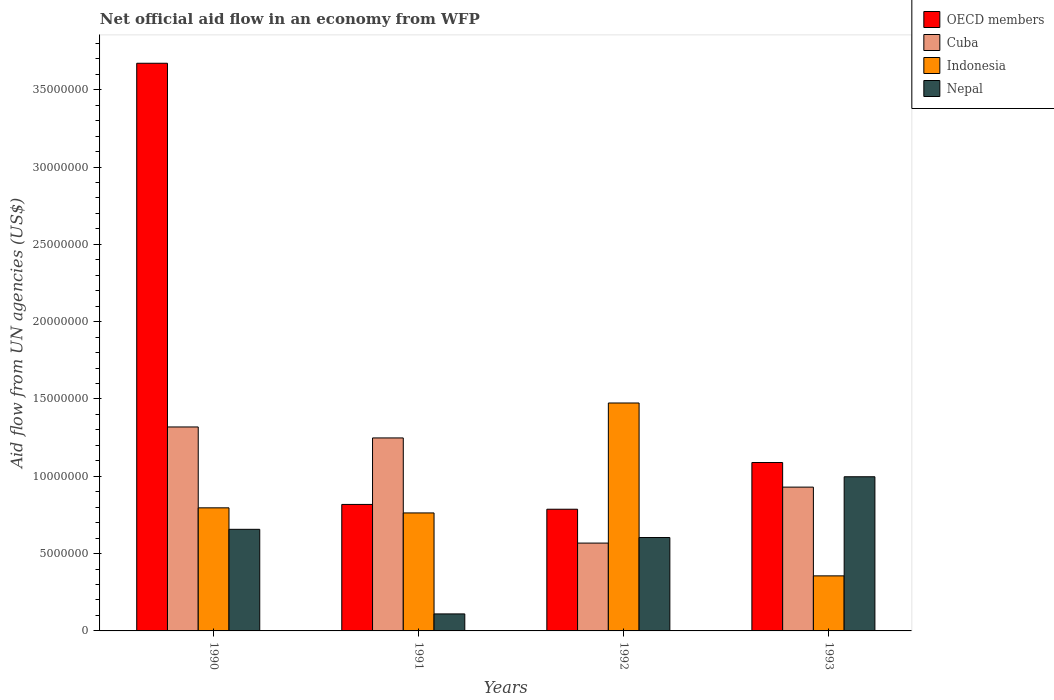How many bars are there on the 1st tick from the left?
Make the answer very short. 4. In how many cases, is the number of bars for a given year not equal to the number of legend labels?
Provide a short and direct response. 0. What is the net official aid flow in Nepal in 1993?
Offer a very short reply. 9.97e+06. Across all years, what is the maximum net official aid flow in Nepal?
Keep it short and to the point. 9.97e+06. Across all years, what is the minimum net official aid flow in Cuba?
Make the answer very short. 5.68e+06. In which year was the net official aid flow in Cuba minimum?
Make the answer very short. 1992. What is the total net official aid flow in Cuba in the graph?
Make the answer very short. 4.06e+07. What is the difference between the net official aid flow in Nepal in 1991 and the net official aid flow in Indonesia in 1990?
Your response must be concise. -6.86e+06. What is the average net official aid flow in OECD members per year?
Ensure brevity in your answer.  1.59e+07. In the year 1990, what is the difference between the net official aid flow in Nepal and net official aid flow in Indonesia?
Your answer should be compact. -1.39e+06. In how many years, is the net official aid flow in Cuba greater than 33000000 US$?
Offer a very short reply. 0. What is the ratio of the net official aid flow in Indonesia in 1991 to that in 1992?
Your answer should be compact. 0.52. What is the difference between the highest and the second highest net official aid flow in Cuba?
Your answer should be very brief. 7.10e+05. What is the difference between the highest and the lowest net official aid flow in Indonesia?
Offer a terse response. 1.12e+07. In how many years, is the net official aid flow in Nepal greater than the average net official aid flow in Nepal taken over all years?
Provide a short and direct response. 3. Is it the case that in every year, the sum of the net official aid flow in Cuba and net official aid flow in Indonesia is greater than the sum of net official aid flow in Nepal and net official aid flow in OECD members?
Offer a terse response. Yes. What does the 4th bar from the left in 1993 represents?
Make the answer very short. Nepal. What does the 4th bar from the right in 1993 represents?
Make the answer very short. OECD members. Are all the bars in the graph horizontal?
Keep it short and to the point. No. What is the difference between two consecutive major ticks on the Y-axis?
Your answer should be compact. 5.00e+06. Are the values on the major ticks of Y-axis written in scientific E-notation?
Offer a very short reply. No. Does the graph contain any zero values?
Provide a succinct answer. No. Where does the legend appear in the graph?
Your response must be concise. Top right. How many legend labels are there?
Keep it short and to the point. 4. How are the legend labels stacked?
Give a very brief answer. Vertical. What is the title of the graph?
Offer a terse response. Net official aid flow in an economy from WFP. Does "Turkey" appear as one of the legend labels in the graph?
Give a very brief answer. No. What is the label or title of the Y-axis?
Give a very brief answer. Aid flow from UN agencies (US$). What is the Aid flow from UN agencies (US$) of OECD members in 1990?
Make the answer very short. 3.67e+07. What is the Aid flow from UN agencies (US$) of Cuba in 1990?
Your answer should be very brief. 1.32e+07. What is the Aid flow from UN agencies (US$) of Indonesia in 1990?
Your response must be concise. 7.96e+06. What is the Aid flow from UN agencies (US$) of Nepal in 1990?
Give a very brief answer. 6.57e+06. What is the Aid flow from UN agencies (US$) of OECD members in 1991?
Make the answer very short. 8.18e+06. What is the Aid flow from UN agencies (US$) of Cuba in 1991?
Provide a short and direct response. 1.25e+07. What is the Aid flow from UN agencies (US$) of Indonesia in 1991?
Provide a succinct answer. 7.63e+06. What is the Aid flow from UN agencies (US$) in Nepal in 1991?
Provide a short and direct response. 1.10e+06. What is the Aid flow from UN agencies (US$) of OECD members in 1992?
Keep it short and to the point. 7.87e+06. What is the Aid flow from UN agencies (US$) in Cuba in 1992?
Provide a short and direct response. 5.68e+06. What is the Aid flow from UN agencies (US$) in Indonesia in 1992?
Your answer should be very brief. 1.47e+07. What is the Aid flow from UN agencies (US$) of Nepal in 1992?
Offer a terse response. 6.04e+06. What is the Aid flow from UN agencies (US$) in OECD members in 1993?
Give a very brief answer. 1.09e+07. What is the Aid flow from UN agencies (US$) in Cuba in 1993?
Offer a very short reply. 9.30e+06. What is the Aid flow from UN agencies (US$) of Indonesia in 1993?
Ensure brevity in your answer.  3.56e+06. What is the Aid flow from UN agencies (US$) in Nepal in 1993?
Give a very brief answer. 9.97e+06. Across all years, what is the maximum Aid flow from UN agencies (US$) in OECD members?
Offer a terse response. 3.67e+07. Across all years, what is the maximum Aid flow from UN agencies (US$) of Cuba?
Keep it short and to the point. 1.32e+07. Across all years, what is the maximum Aid flow from UN agencies (US$) of Indonesia?
Provide a short and direct response. 1.47e+07. Across all years, what is the maximum Aid flow from UN agencies (US$) of Nepal?
Provide a short and direct response. 9.97e+06. Across all years, what is the minimum Aid flow from UN agencies (US$) in OECD members?
Your response must be concise. 7.87e+06. Across all years, what is the minimum Aid flow from UN agencies (US$) of Cuba?
Offer a terse response. 5.68e+06. Across all years, what is the minimum Aid flow from UN agencies (US$) in Indonesia?
Ensure brevity in your answer.  3.56e+06. Across all years, what is the minimum Aid flow from UN agencies (US$) in Nepal?
Make the answer very short. 1.10e+06. What is the total Aid flow from UN agencies (US$) in OECD members in the graph?
Keep it short and to the point. 6.36e+07. What is the total Aid flow from UN agencies (US$) in Cuba in the graph?
Provide a short and direct response. 4.06e+07. What is the total Aid flow from UN agencies (US$) of Indonesia in the graph?
Make the answer very short. 3.39e+07. What is the total Aid flow from UN agencies (US$) in Nepal in the graph?
Offer a very short reply. 2.37e+07. What is the difference between the Aid flow from UN agencies (US$) in OECD members in 1990 and that in 1991?
Provide a short and direct response. 2.85e+07. What is the difference between the Aid flow from UN agencies (US$) of Cuba in 1990 and that in 1991?
Offer a terse response. 7.10e+05. What is the difference between the Aid flow from UN agencies (US$) in Nepal in 1990 and that in 1991?
Offer a terse response. 5.47e+06. What is the difference between the Aid flow from UN agencies (US$) of OECD members in 1990 and that in 1992?
Make the answer very short. 2.88e+07. What is the difference between the Aid flow from UN agencies (US$) in Cuba in 1990 and that in 1992?
Ensure brevity in your answer.  7.51e+06. What is the difference between the Aid flow from UN agencies (US$) in Indonesia in 1990 and that in 1992?
Give a very brief answer. -6.78e+06. What is the difference between the Aid flow from UN agencies (US$) of Nepal in 1990 and that in 1992?
Your response must be concise. 5.30e+05. What is the difference between the Aid flow from UN agencies (US$) of OECD members in 1990 and that in 1993?
Your answer should be very brief. 2.58e+07. What is the difference between the Aid flow from UN agencies (US$) of Cuba in 1990 and that in 1993?
Make the answer very short. 3.89e+06. What is the difference between the Aid flow from UN agencies (US$) in Indonesia in 1990 and that in 1993?
Offer a very short reply. 4.40e+06. What is the difference between the Aid flow from UN agencies (US$) in Nepal in 1990 and that in 1993?
Your answer should be very brief. -3.40e+06. What is the difference between the Aid flow from UN agencies (US$) of Cuba in 1991 and that in 1992?
Give a very brief answer. 6.80e+06. What is the difference between the Aid flow from UN agencies (US$) of Indonesia in 1991 and that in 1992?
Offer a very short reply. -7.11e+06. What is the difference between the Aid flow from UN agencies (US$) in Nepal in 1991 and that in 1992?
Make the answer very short. -4.94e+06. What is the difference between the Aid flow from UN agencies (US$) of OECD members in 1991 and that in 1993?
Ensure brevity in your answer.  -2.71e+06. What is the difference between the Aid flow from UN agencies (US$) in Cuba in 1991 and that in 1993?
Provide a succinct answer. 3.18e+06. What is the difference between the Aid flow from UN agencies (US$) in Indonesia in 1991 and that in 1993?
Offer a very short reply. 4.07e+06. What is the difference between the Aid flow from UN agencies (US$) in Nepal in 1991 and that in 1993?
Offer a very short reply. -8.87e+06. What is the difference between the Aid flow from UN agencies (US$) of OECD members in 1992 and that in 1993?
Your response must be concise. -3.02e+06. What is the difference between the Aid flow from UN agencies (US$) in Cuba in 1992 and that in 1993?
Your answer should be very brief. -3.62e+06. What is the difference between the Aid flow from UN agencies (US$) of Indonesia in 1992 and that in 1993?
Make the answer very short. 1.12e+07. What is the difference between the Aid flow from UN agencies (US$) in Nepal in 1992 and that in 1993?
Offer a terse response. -3.93e+06. What is the difference between the Aid flow from UN agencies (US$) of OECD members in 1990 and the Aid flow from UN agencies (US$) of Cuba in 1991?
Your answer should be compact. 2.42e+07. What is the difference between the Aid flow from UN agencies (US$) in OECD members in 1990 and the Aid flow from UN agencies (US$) in Indonesia in 1991?
Ensure brevity in your answer.  2.91e+07. What is the difference between the Aid flow from UN agencies (US$) in OECD members in 1990 and the Aid flow from UN agencies (US$) in Nepal in 1991?
Offer a very short reply. 3.56e+07. What is the difference between the Aid flow from UN agencies (US$) of Cuba in 1990 and the Aid flow from UN agencies (US$) of Indonesia in 1991?
Your response must be concise. 5.56e+06. What is the difference between the Aid flow from UN agencies (US$) in Cuba in 1990 and the Aid flow from UN agencies (US$) in Nepal in 1991?
Offer a terse response. 1.21e+07. What is the difference between the Aid flow from UN agencies (US$) of Indonesia in 1990 and the Aid flow from UN agencies (US$) of Nepal in 1991?
Your answer should be compact. 6.86e+06. What is the difference between the Aid flow from UN agencies (US$) of OECD members in 1990 and the Aid flow from UN agencies (US$) of Cuba in 1992?
Make the answer very short. 3.10e+07. What is the difference between the Aid flow from UN agencies (US$) in OECD members in 1990 and the Aid flow from UN agencies (US$) in Indonesia in 1992?
Give a very brief answer. 2.20e+07. What is the difference between the Aid flow from UN agencies (US$) in OECD members in 1990 and the Aid flow from UN agencies (US$) in Nepal in 1992?
Keep it short and to the point. 3.07e+07. What is the difference between the Aid flow from UN agencies (US$) in Cuba in 1990 and the Aid flow from UN agencies (US$) in Indonesia in 1992?
Provide a short and direct response. -1.55e+06. What is the difference between the Aid flow from UN agencies (US$) of Cuba in 1990 and the Aid flow from UN agencies (US$) of Nepal in 1992?
Keep it short and to the point. 7.15e+06. What is the difference between the Aid flow from UN agencies (US$) in Indonesia in 1990 and the Aid flow from UN agencies (US$) in Nepal in 1992?
Your response must be concise. 1.92e+06. What is the difference between the Aid flow from UN agencies (US$) in OECD members in 1990 and the Aid flow from UN agencies (US$) in Cuba in 1993?
Ensure brevity in your answer.  2.74e+07. What is the difference between the Aid flow from UN agencies (US$) in OECD members in 1990 and the Aid flow from UN agencies (US$) in Indonesia in 1993?
Your response must be concise. 3.32e+07. What is the difference between the Aid flow from UN agencies (US$) of OECD members in 1990 and the Aid flow from UN agencies (US$) of Nepal in 1993?
Keep it short and to the point. 2.67e+07. What is the difference between the Aid flow from UN agencies (US$) in Cuba in 1990 and the Aid flow from UN agencies (US$) in Indonesia in 1993?
Provide a short and direct response. 9.63e+06. What is the difference between the Aid flow from UN agencies (US$) in Cuba in 1990 and the Aid flow from UN agencies (US$) in Nepal in 1993?
Provide a succinct answer. 3.22e+06. What is the difference between the Aid flow from UN agencies (US$) of Indonesia in 1990 and the Aid flow from UN agencies (US$) of Nepal in 1993?
Your response must be concise. -2.01e+06. What is the difference between the Aid flow from UN agencies (US$) of OECD members in 1991 and the Aid flow from UN agencies (US$) of Cuba in 1992?
Ensure brevity in your answer.  2.50e+06. What is the difference between the Aid flow from UN agencies (US$) of OECD members in 1991 and the Aid flow from UN agencies (US$) of Indonesia in 1992?
Your response must be concise. -6.56e+06. What is the difference between the Aid flow from UN agencies (US$) of OECD members in 1991 and the Aid flow from UN agencies (US$) of Nepal in 1992?
Provide a short and direct response. 2.14e+06. What is the difference between the Aid flow from UN agencies (US$) of Cuba in 1991 and the Aid flow from UN agencies (US$) of Indonesia in 1992?
Provide a succinct answer. -2.26e+06. What is the difference between the Aid flow from UN agencies (US$) of Cuba in 1991 and the Aid flow from UN agencies (US$) of Nepal in 1992?
Ensure brevity in your answer.  6.44e+06. What is the difference between the Aid flow from UN agencies (US$) of Indonesia in 1991 and the Aid flow from UN agencies (US$) of Nepal in 1992?
Your answer should be compact. 1.59e+06. What is the difference between the Aid flow from UN agencies (US$) in OECD members in 1991 and the Aid flow from UN agencies (US$) in Cuba in 1993?
Provide a short and direct response. -1.12e+06. What is the difference between the Aid flow from UN agencies (US$) in OECD members in 1991 and the Aid flow from UN agencies (US$) in Indonesia in 1993?
Offer a terse response. 4.62e+06. What is the difference between the Aid flow from UN agencies (US$) in OECD members in 1991 and the Aid flow from UN agencies (US$) in Nepal in 1993?
Make the answer very short. -1.79e+06. What is the difference between the Aid flow from UN agencies (US$) in Cuba in 1991 and the Aid flow from UN agencies (US$) in Indonesia in 1993?
Make the answer very short. 8.92e+06. What is the difference between the Aid flow from UN agencies (US$) of Cuba in 1991 and the Aid flow from UN agencies (US$) of Nepal in 1993?
Make the answer very short. 2.51e+06. What is the difference between the Aid flow from UN agencies (US$) of Indonesia in 1991 and the Aid flow from UN agencies (US$) of Nepal in 1993?
Your answer should be very brief. -2.34e+06. What is the difference between the Aid flow from UN agencies (US$) in OECD members in 1992 and the Aid flow from UN agencies (US$) in Cuba in 1993?
Ensure brevity in your answer.  -1.43e+06. What is the difference between the Aid flow from UN agencies (US$) in OECD members in 1992 and the Aid flow from UN agencies (US$) in Indonesia in 1993?
Ensure brevity in your answer.  4.31e+06. What is the difference between the Aid flow from UN agencies (US$) in OECD members in 1992 and the Aid flow from UN agencies (US$) in Nepal in 1993?
Keep it short and to the point. -2.10e+06. What is the difference between the Aid flow from UN agencies (US$) of Cuba in 1992 and the Aid flow from UN agencies (US$) of Indonesia in 1993?
Provide a short and direct response. 2.12e+06. What is the difference between the Aid flow from UN agencies (US$) of Cuba in 1992 and the Aid flow from UN agencies (US$) of Nepal in 1993?
Give a very brief answer. -4.29e+06. What is the difference between the Aid flow from UN agencies (US$) in Indonesia in 1992 and the Aid flow from UN agencies (US$) in Nepal in 1993?
Offer a very short reply. 4.77e+06. What is the average Aid flow from UN agencies (US$) of OECD members per year?
Offer a terse response. 1.59e+07. What is the average Aid flow from UN agencies (US$) in Cuba per year?
Provide a short and direct response. 1.02e+07. What is the average Aid flow from UN agencies (US$) in Indonesia per year?
Give a very brief answer. 8.47e+06. What is the average Aid flow from UN agencies (US$) of Nepal per year?
Ensure brevity in your answer.  5.92e+06. In the year 1990, what is the difference between the Aid flow from UN agencies (US$) in OECD members and Aid flow from UN agencies (US$) in Cuba?
Offer a terse response. 2.35e+07. In the year 1990, what is the difference between the Aid flow from UN agencies (US$) of OECD members and Aid flow from UN agencies (US$) of Indonesia?
Provide a succinct answer. 2.88e+07. In the year 1990, what is the difference between the Aid flow from UN agencies (US$) of OECD members and Aid flow from UN agencies (US$) of Nepal?
Your response must be concise. 3.01e+07. In the year 1990, what is the difference between the Aid flow from UN agencies (US$) of Cuba and Aid flow from UN agencies (US$) of Indonesia?
Offer a terse response. 5.23e+06. In the year 1990, what is the difference between the Aid flow from UN agencies (US$) in Cuba and Aid flow from UN agencies (US$) in Nepal?
Offer a very short reply. 6.62e+06. In the year 1990, what is the difference between the Aid flow from UN agencies (US$) in Indonesia and Aid flow from UN agencies (US$) in Nepal?
Offer a very short reply. 1.39e+06. In the year 1991, what is the difference between the Aid flow from UN agencies (US$) of OECD members and Aid flow from UN agencies (US$) of Cuba?
Ensure brevity in your answer.  -4.30e+06. In the year 1991, what is the difference between the Aid flow from UN agencies (US$) in OECD members and Aid flow from UN agencies (US$) in Indonesia?
Provide a short and direct response. 5.50e+05. In the year 1991, what is the difference between the Aid flow from UN agencies (US$) in OECD members and Aid flow from UN agencies (US$) in Nepal?
Provide a succinct answer. 7.08e+06. In the year 1991, what is the difference between the Aid flow from UN agencies (US$) of Cuba and Aid flow from UN agencies (US$) of Indonesia?
Keep it short and to the point. 4.85e+06. In the year 1991, what is the difference between the Aid flow from UN agencies (US$) in Cuba and Aid flow from UN agencies (US$) in Nepal?
Ensure brevity in your answer.  1.14e+07. In the year 1991, what is the difference between the Aid flow from UN agencies (US$) in Indonesia and Aid flow from UN agencies (US$) in Nepal?
Your answer should be very brief. 6.53e+06. In the year 1992, what is the difference between the Aid flow from UN agencies (US$) in OECD members and Aid flow from UN agencies (US$) in Cuba?
Give a very brief answer. 2.19e+06. In the year 1992, what is the difference between the Aid flow from UN agencies (US$) in OECD members and Aid flow from UN agencies (US$) in Indonesia?
Provide a short and direct response. -6.87e+06. In the year 1992, what is the difference between the Aid flow from UN agencies (US$) in OECD members and Aid flow from UN agencies (US$) in Nepal?
Offer a terse response. 1.83e+06. In the year 1992, what is the difference between the Aid flow from UN agencies (US$) in Cuba and Aid flow from UN agencies (US$) in Indonesia?
Make the answer very short. -9.06e+06. In the year 1992, what is the difference between the Aid flow from UN agencies (US$) of Cuba and Aid flow from UN agencies (US$) of Nepal?
Make the answer very short. -3.60e+05. In the year 1992, what is the difference between the Aid flow from UN agencies (US$) in Indonesia and Aid flow from UN agencies (US$) in Nepal?
Your answer should be compact. 8.70e+06. In the year 1993, what is the difference between the Aid flow from UN agencies (US$) of OECD members and Aid flow from UN agencies (US$) of Cuba?
Your response must be concise. 1.59e+06. In the year 1993, what is the difference between the Aid flow from UN agencies (US$) in OECD members and Aid flow from UN agencies (US$) in Indonesia?
Offer a terse response. 7.33e+06. In the year 1993, what is the difference between the Aid flow from UN agencies (US$) in OECD members and Aid flow from UN agencies (US$) in Nepal?
Offer a very short reply. 9.20e+05. In the year 1993, what is the difference between the Aid flow from UN agencies (US$) in Cuba and Aid flow from UN agencies (US$) in Indonesia?
Offer a very short reply. 5.74e+06. In the year 1993, what is the difference between the Aid flow from UN agencies (US$) of Cuba and Aid flow from UN agencies (US$) of Nepal?
Offer a terse response. -6.70e+05. In the year 1993, what is the difference between the Aid flow from UN agencies (US$) in Indonesia and Aid flow from UN agencies (US$) in Nepal?
Offer a very short reply. -6.41e+06. What is the ratio of the Aid flow from UN agencies (US$) of OECD members in 1990 to that in 1991?
Your answer should be compact. 4.49. What is the ratio of the Aid flow from UN agencies (US$) in Cuba in 1990 to that in 1991?
Provide a short and direct response. 1.06. What is the ratio of the Aid flow from UN agencies (US$) in Indonesia in 1990 to that in 1991?
Your answer should be very brief. 1.04. What is the ratio of the Aid flow from UN agencies (US$) of Nepal in 1990 to that in 1991?
Offer a very short reply. 5.97. What is the ratio of the Aid flow from UN agencies (US$) of OECD members in 1990 to that in 1992?
Ensure brevity in your answer.  4.66. What is the ratio of the Aid flow from UN agencies (US$) of Cuba in 1990 to that in 1992?
Your response must be concise. 2.32. What is the ratio of the Aid flow from UN agencies (US$) of Indonesia in 1990 to that in 1992?
Your answer should be compact. 0.54. What is the ratio of the Aid flow from UN agencies (US$) of Nepal in 1990 to that in 1992?
Your response must be concise. 1.09. What is the ratio of the Aid flow from UN agencies (US$) in OECD members in 1990 to that in 1993?
Provide a succinct answer. 3.37. What is the ratio of the Aid flow from UN agencies (US$) in Cuba in 1990 to that in 1993?
Provide a succinct answer. 1.42. What is the ratio of the Aid flow from UN agencies (US$) in Indonesia in 1990 to that in 1993?
Provide a short and direct response. 2.24. What is the ratio of the Aid flow from UN agencies (US$) of Nepal in 1990 to that in 1993?
Ensure brevity in your answer.  0.66. What is the ratio of the Aid flow from UN agencies (US$) of OECD members in 1991 to that in 1992?
Your answer should be compact. 1.04. What is the ratio of the Aid flow from UN agencies (US$) of Cuba in 1991 to that in 1992?
Your answer should be compact. 2.2. What is the ratio of the Aid flow from UN agencies (US$) in Indonesia in 1991 to that in 1992?
Provide a succinct answer. 0.52. What is the ratio of the Aid flow from UN agencies (US$) of Nepal in 1991 to that in 1992?
Offer a very short reply. 0.18. What is the ratio of the Aid flow from UN agencies (US$) in OECD members in 1991 to that in 1993?
Provide a succinct answer. 0.75. What is the ratio of the Aid flow from UN agencies (US$) of Cuba in 1991 to that in 1993?
Your answer should be very brief. 1.34. What is the ratio of the Aid flow from UN agencies (US$) of Indonesia in 1991 to that in 1993?
Offer a terse response. 2.14. What is the ratio of the Aid flow from UN agencies (US$) in Nepal in 1991 to that in 1993?
Your answer should be compact. 0.11. What is the ratio of the Aid flow from UN agencies (US$) in OECD members in 1992 to that in 1993?
Your answer should be very brief. 0.72. What is the ratio of the Aid flow from UN agencies (US$) of Cuba in 1992 to that in 1993?
Keep it short and to the point. 0.61. What is the ratio of the Aid flow from UN agencies (US$) of Indonesia in 1992 to that in 1993?
Make the answer very short. 4.14. What is the ratio of the Aid flow from UN agencies (US$) of Nepal in 1992 to that in 1993?
Your response must be concise. 0.61. What is the difference between the highest and the second highest Aid flow from UN agencies (US$) in OECD members?
Your answer should be very brief. 2.58e+07. What is the difference between the highest and the second highest Aid flow from UN agencies (US$) in Cuba?
Give a very brief answer. 7.10e+05. What is the difference between the highest and the second highest Aid flow from UN agencies (US$) in Indonesia?
Provide a succinct answer. 6.78e+06. What is the difference between the highest and the second highest Aid flow from UN agencies (US$) of Nepal?
Keep it short and to the point. 3.40e+06. What is the difference between the highest and the lowest Aid flow from UN agencies (US$) in OECD members?
Provide a succinct answer. 2.88e+07. What is the difference between the highest and the lowest Aid flow from UN agencies (US$) in Cuba?
Your answer should be very brief. 7.51e+06. What is the difference between the highest and the lowest Aid flow from UN agencies (US$) of Indonesia?
Ensure brevity in your answer.  1.12e+07. What is the difference between the highest and the lowest Aid flow from UN agencies (US$) of Nepal?
Your answer should be very brief. 8.87e+06. 